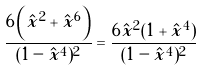Convert formula to latex. <formula><loc_0><loc_0><loc_500><loc_500>\frac { 6 \left ( \hat { x } ^ { 2 } + \hat { x } ^ { 6 } \right ) } { ( 1 - \hat { x } ^ { 4 } ) ^ { 2 } } = \frac { 6 \hat { x } ^ { 2 } ( 1 + \hat { x } ^ { 4 } ) } { ( 1 - \hat { x } ^ { 4 } ) ^ { 2 } }</formula> 